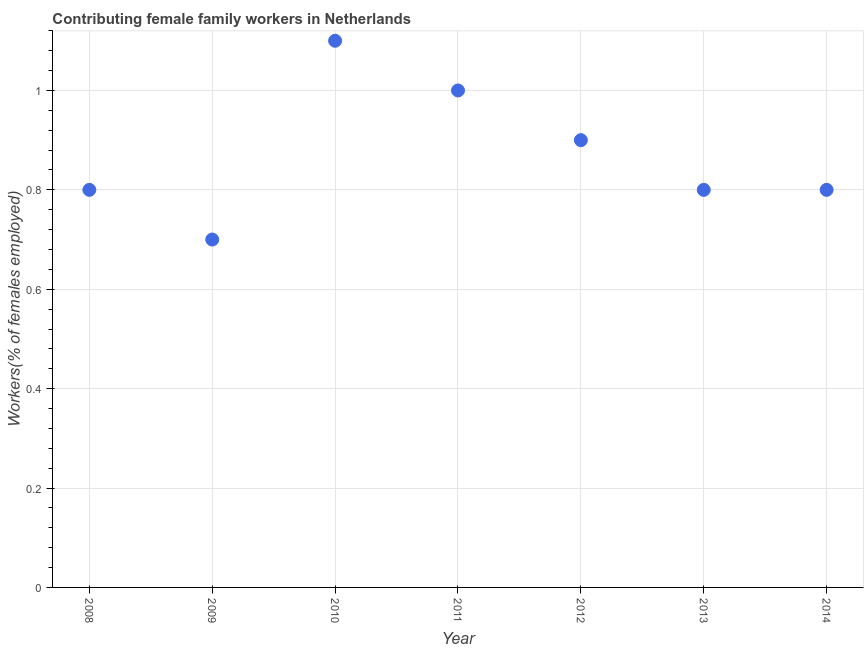What is the contributing female family workers in 2009?
Your response must be concise. 0.7. Across all years, what is the maximum contributing female family workers?
Offer a very short reply. 1.1. Across all years, what is the minimum contributing female family workers?
Offer a very short reply. 0.7. In which year was the contributing female family workers maximum?
Your response must be concise. 2010. What is the sum of the contributing female family workers?
Keep it short and to the point. 6.1. What is the difference between the contributing female family workers in 2010 and 2012?
Provide a succinct answer. 0.2. What is the average contributing female family workers per year?
Your answer should be very brief. 0.87. What is the median contributing female family workers?
Ensure brevity in your answer.  0.8. What is the ratio of the contributing female family workers in 2008 to that in 2010?
Keep it short and to the point. 0.73. What is the difference between the highest and the second highest contributing female family workers?
Offer a terse response. 0.1. Is the sum of the contributing female family workers in 2011 and 2012 greater than the maximum contributing female family workers across all years?
Ensure brevity in your answer.  Yes. What is the difference between the highest and the lowest contributing female family workers?
Keep it short and to the point. 0.4. In how many years, is the contributing female family workers greater than the average contributing female family workers taken over all years?
Offer a very short reply. 3. Does the contributing female family workers monotonically increase over the years?
Provide a short and direct response. No. How many years are there in the graph?
Your answer should be very brief. 7. Are the values on the major ticks of Y-axis written in scientific E-notation?
Your answer should be very brief. No. What is the title of the graph?
Offer a terse response. Contributing female family workers in Netherlands. What is the label or title of the Y-axis?
Make the answer very short. Workers(% of females employed). What is the Workers(% of females employed) in 2008?
Your answer should be very brief. 0.8. What is the Workers(% of females employed) in 2009?
Your answer should be compact. 0.7. What is the Workers(% of females employed) in 2010?
Your response must be concise. 1.1. What is the Workers(% of females employed) in 2011?
Provide a short and direct response. 1. What is the Workers(% of females employed) in 2012?
Provide a succinct answer. 0.9. What is the Workers(% of females employed) in 2013?
Your response must be concise. 0.8. What is the Workers(% of females employed) in 2014?
Your response must be concise. 0.8. What is the difference between the Workers(% of females employed) in 2008 and 2009?
Give a very brief answer. 0.1. What is the difference between the Workers(% of females employed) in 2008 and 2010?
Provide a short and direct response. -0.3. What is the difference between the Workers(% of females employed) in 2008 and 2012?
Ensure brevity in your answer.  -0.1. What is the difference between the Workers(% of females employed) in 2008 and 2013?
Ensure brevity in your answer.  0. What is the difference between the Workers(% of females employed) in 2008 and 2014?
Give a very brief answer. 0. What is the difference between the Workers(% of females employed) in 2009 and 2011?
Provide a short and direct response. -0.3. What is the difference between the Workers(% of females employed) in 2009 and 2012?
Offer a very short reply. -0.2. What is the difference between the Workers(% of females employed) in 2010 and 2011?
Provide a succinct answer. 0.1. What is the difference between the Workers(% of females employed) in 2010 and 2012?
Provide a succinct answer. 0.2. What is the difference between the Workers(% of females employed) in 2011 and 2014?
Offer a very short reply. 0.2. What is the difference between the Workers(% of females employed) in 2012 and 2014?
Your answer should be very brief. 0.1. What is the difference between the Workers(% of females employed) in 2013 and 2014?
Provide a short and direct response. 0. What is the ratio of the Workers(% of females employed) in 2008 to that in 2009?
Provide a succinct answer. 1.14. What is the ratio of the Workers(% of females employed) in 2008 to that in 2010?
Your answer should be very brief. 0.73. What is the ratio of the Workers(% of females employed) in 2008 to that in 2012?
Ensure brevity in your answer.  0.89. What is the ratio of the Workers(% of females employed) in 2008 to that in 2014?
Your response must be concise. 1. What is the ratio of the Workers(% of females employed) in 2009 to that in 2010?
Ensure brevity in your answer.  0.64. What is the ratio of the Workers(% of females employed) in 2009 to that in 2011?
Provide a succinct answer. 0.7. What is the ratio of the Workers(% of females employed) in 2009 to that in 2012?
Your response must be concise. 0.78. What is the ratio of the Workers(% of females employed) in 2009 to that in 2014?
Your answer should be compact. 0.88. What is the ratio of the Workers(% of females employed) in 2010 to that in 2012?
Make the answer very short. 1.22. What is the ratio of the Workers(% of females employed) in 2010 to that in 2013?
Provide a short and direct response. 1.38. What is the ratio of the Workers(% of females employed) in 2010 to that in 2014?
Keep it short and to the point. 1.38. What is the ratio of the Workers(% of females employed) in 2011 to that in 2012?
Provide a succinct answer. 1.11. What is the ratio of the Workers(% of females employed) in 2011 to that in 2014?
Make the answer very short. 1.25. What is the ratio of the Workers(% of females employed) in 2012 to that in 2013?
Ensure brevity in your answer.  1.12. What is the ratio of the Workers(% of females employed) in 2012 to that in 2014?
Offer a terse response. 1.12. What is the ratio of the Workers(% of females employed) in 2013 to that in 2014?
Your answer should be very brief. 1. 